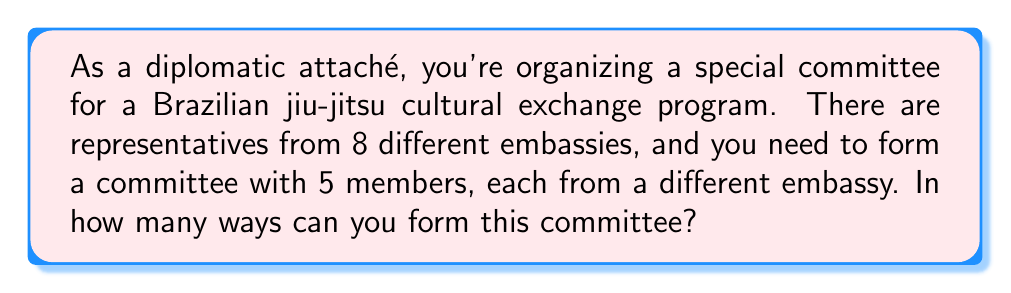Help me with this question. Let's approach this step-by-step:

1) This is a combination problem. We are selecting 5 representatives out of 8 embassies, where the order doesn't matter (it's a committee, not a lineup).

2) The formula for combinations is:

   $$C(n,r) = \frac{n!}{r!(n-r)!}$$

   Where $n$ is the total number of items to choose from, and $r$ is the number of items being chosen.

3) In this case, $n = 8$ (total number of embassies) and $r = 5$ (number of committee members).

4) Plugging these values into our formula:

   $$C(8,5) = \frac{8!}{5!(8-5)!} = \frac{8!}{5!3!}$$

5) Let's calculate this:
   
   $$\frac{8!}{5!3!} = \frac{8 \times 7 \times 6 \times 5!}{5! \times 3 \times 2 \times 1}$$

6) The $5!$ cancels out in the numerator and denominator:

   $$\frac{8 \times 7 \times 6}{3 \times 2 \times 1} = \frac{336}{6} = 56$$

Therefore, there are 56 different ways to form the committee.
Answer: 56 